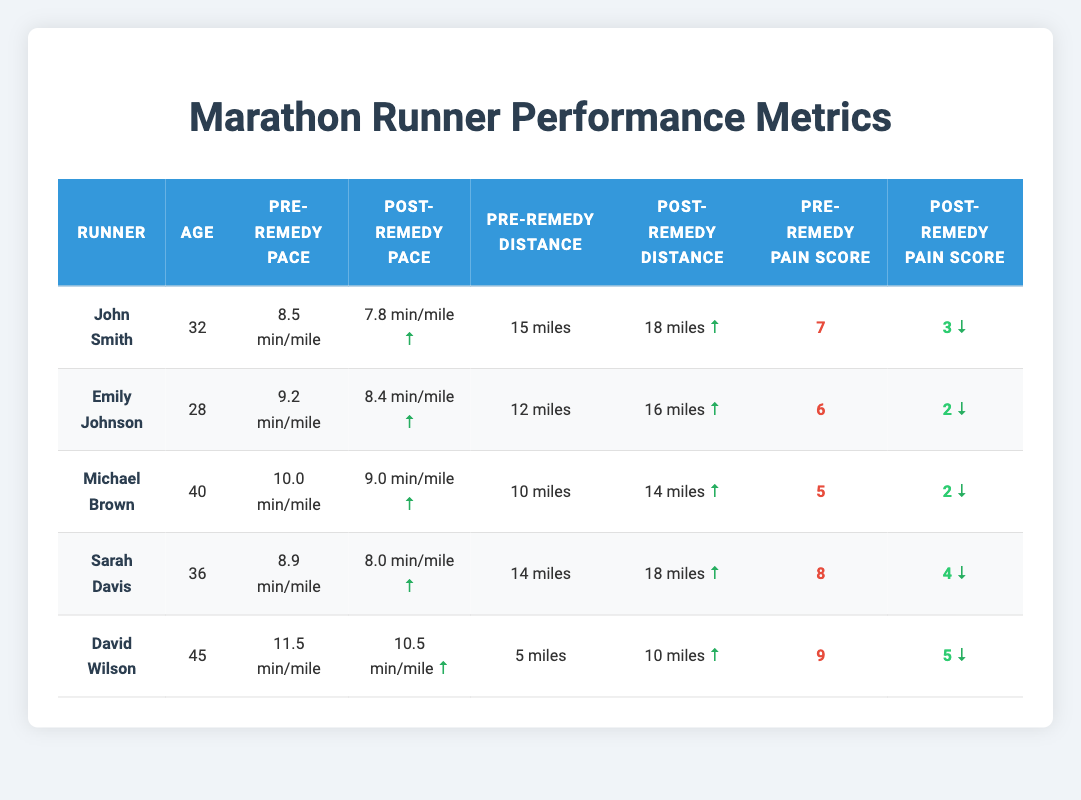What was John Smith's pre-remedy pace? John Smith's pre-remedy pace is listed in the table under the column "Pre-Remedy Pace," where it shows 8.5 min/mile.
Answer: 8.5 min/mile How much did Emily Johnson improve her post-remedy distance compared to her pre-remedy distance? To find the improvement for Emily Johnson, we subtract her pre-remedy distance (12 miles) from her post-remedy distance (16 miles): 16 - 12 = 4 miles.
Answer: 4 miles True or False: Michael Brown's knee pain score decreased more than John Smith's. Michael Brown's pre-remedy pain score is 5 and post-remedy is 2, a decrease of 3. John Smith's scores are 7 pre-remedy and 3 post-remedy, a decrease of 4. Since 3 < 4, the statement is False.
Answer: False What is the average pre-remedy pace of all runners? The pre-remedy paces are: 8.5, 9.2, 10.0, 8.9, and 11.5 min/mile. Summing these gives 8.5 + 9.2 + 10.0 + 8.9 + 11.5 = 58.1. There are 5 runners, so the average is 58.1 / 5 = 11.62 min/mile.
Answer: 11.62 min/mile Who had the highest pre-remedy pain score, and what was it? To find the highest pre-remedy pain score, we compare all scores: 7 (John), 6 (Emily), 5 (Michael), 8 (Sarah), and 9 (David). The highest score is David's, which is 9.
Answer: David Wilson, 9 